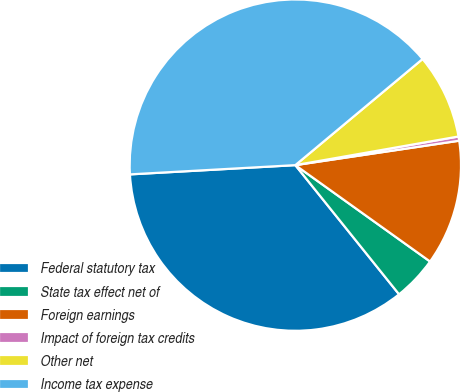Convert chart to OTSL. <chart><loc_0><loc_0><loc_500><loc_500><pie_chart><fcel>Federal statutory tax<fcel>State tax effect net of<fcel>Foreign earnings<fcel>Impact of foreign tax credits<fcel>Other net<fcel>Income tax expense<nl><fcel>34.88%<fcel>4.35%<fcel>12.24%<fcel>0.41%<fcel>8.3%<fcel>39.83%<nl></chart> 